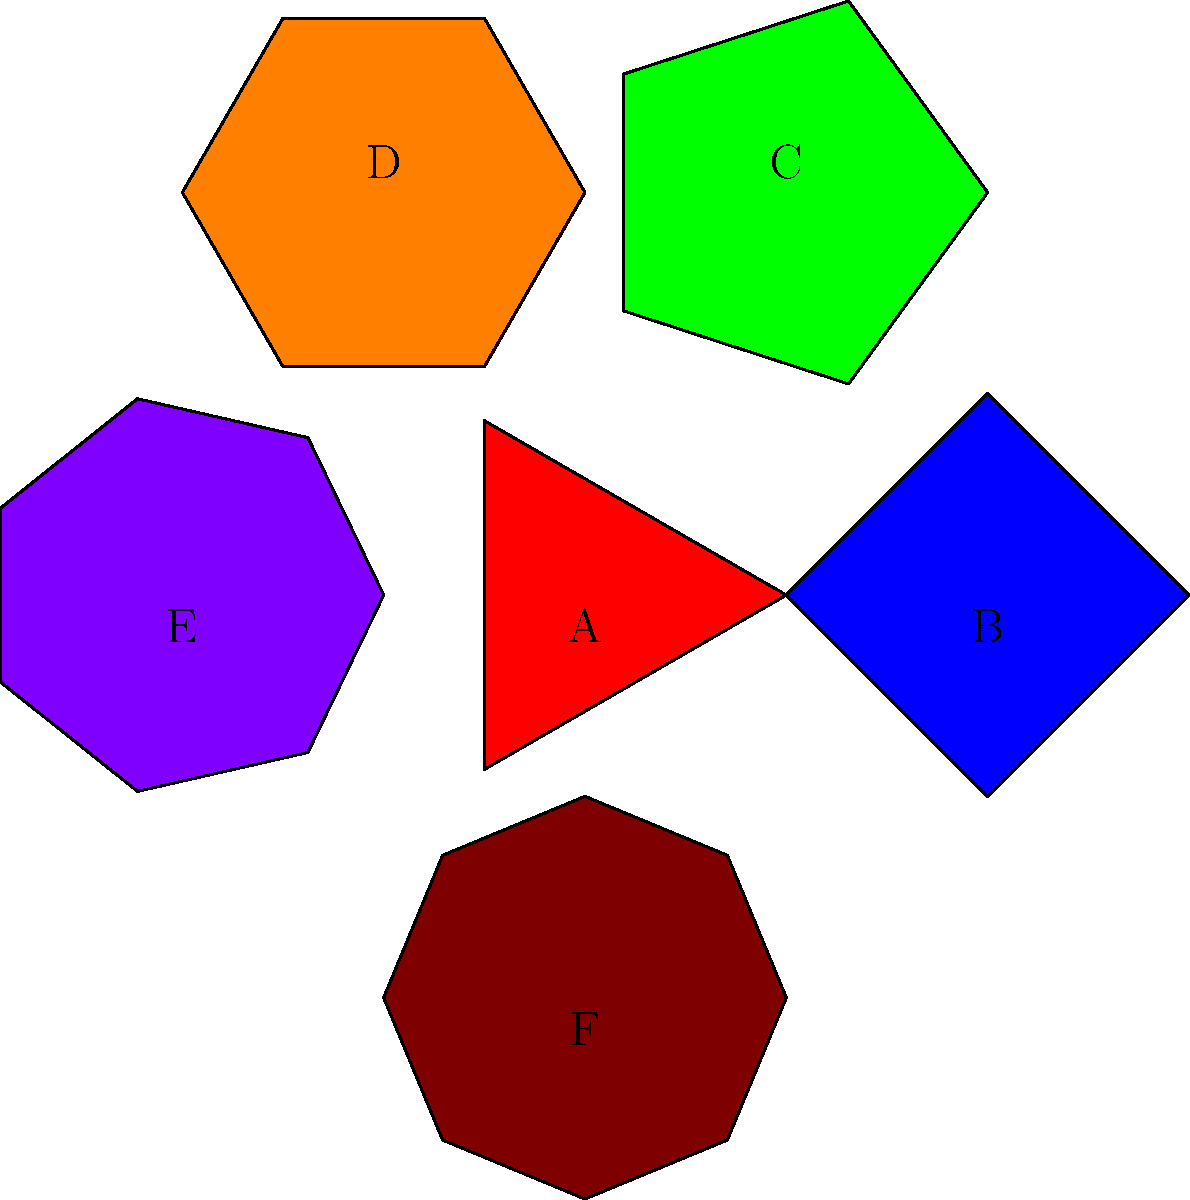Match the shapes to their corresponding instruments:

1. Kudyapi (Filipino stringed instrument)
2. Oud (Middle Eastern lute)
3. Kulintang (Filipino gong set)
4. Darbuka (Middle Eastern goblet drum)
5. Tongali (Filipino nose flute)
6. Qanun (Middle Eastern zither)

Which letter corresponds to the shape of the Darbuka? To solve this problem, let's analyze each shape and match it to the corresponding instrument:

1. Shape A: Triangle (3 sides) - This represents the Kudyapi, a Filipino stringed instrument often with a triangular body.

2. Shape B: Square (4 sides) - This represents the Oud, a Middle Eastern lute with a pear-shaped body, simplified here as a square.

3. Shape C: Pentagon (5 sides) - This represents the Kulintang, a Filipino gong set typically consisting of 5-8 small gongs.

4. Shape D: Hexagon (6 sides) - This represents the Darbuka, a Middle Eastern goblet drum with a distinctive six-sided shape when viewed from above.

5. Shape E: Heptagon (7 sides) - This represents the Tongali, a Filipino nose flute, simplified here as a seven-sided shape.

6. Shape F: Octagon (8 sides) - This represents the Qanun, a Middle Eastern zither with a trapezoidal shape, simplified here as an octagon.

The question asks specifically for the shape corresponding to the Darbuka. From our analysis, we can see that the Darbuka is represented by the hexagon, which is labeled as D in the diagram.
Answer: D 